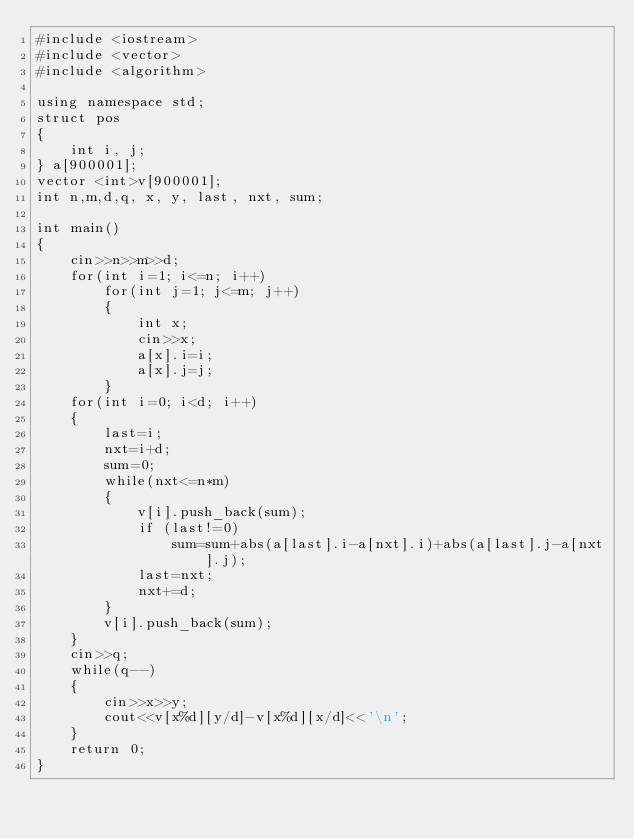Convert code to text. <code><loc_0><loc_0><loc_500><loc_500><_C++_>#include <iostream>
#include <vector>
#include <algorithm>

using namespace std;
struct pos
{
    int i, j;
} a[900001];
vector <int>v[900001];
int n,m,d,q, x, y, last, nxt, sum;

int main()
{
    cin>>n>>m>>d;
    for(int i=1; i<=n; i++)
        for(int j=1; j<=m; j++)
        {
            int x;
            cin>>x;
            a[x].i=i;
            a[x].j=j;
        }
    for(int i=0; i<d; i++)
    {
        last=i;
        nxt=i+d;
        sum=0;
        while(nxt<=n*m)
        {
            v[i].push_back(sum);
            if (last!=0)
                sum=sum+abs(a[last].i-a[nxt].i)+abs(a[last].j-a[nxt].j);
            last=nxt;
            nxt+=d;
        }
        v[i].push_back(sum);
    }
    cin>>q;
    while(q--)
    {
        cin>>x>>y;
        cout<<v[x%d][y/d]-v[x%d][x/d]<<'\n';
    }
    return 0;
}
</code> 